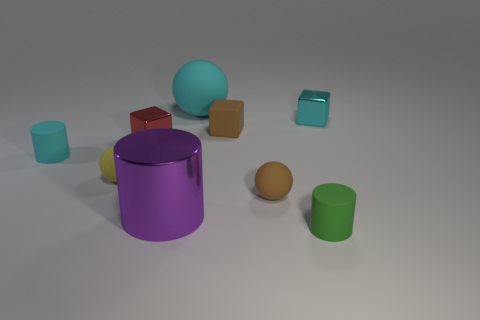Subtract all cyan spheres. How many spheres are left? 2 Subtract all big purple cylinders. How many cylinders are left? 2 Subtract all purple cubes. How many cyan balls are left? 1 Subtract 1 cyan balls. How many objects are left? 8 Subtract all spheres. How many objects are left? 6 Subtract 2 blocks. How many blocks are left? 1 Subtract all purple blocks. Subtract all yellow balls. How many blocks are left? 3 Subtract all small yellow rubber blocks. Subtract all tiny brown blocks. How many objects are left? 8 Add 9 small green things. How many small green things are left? 10 Add 5 big cylinders. How many big cylinders exist? 6 